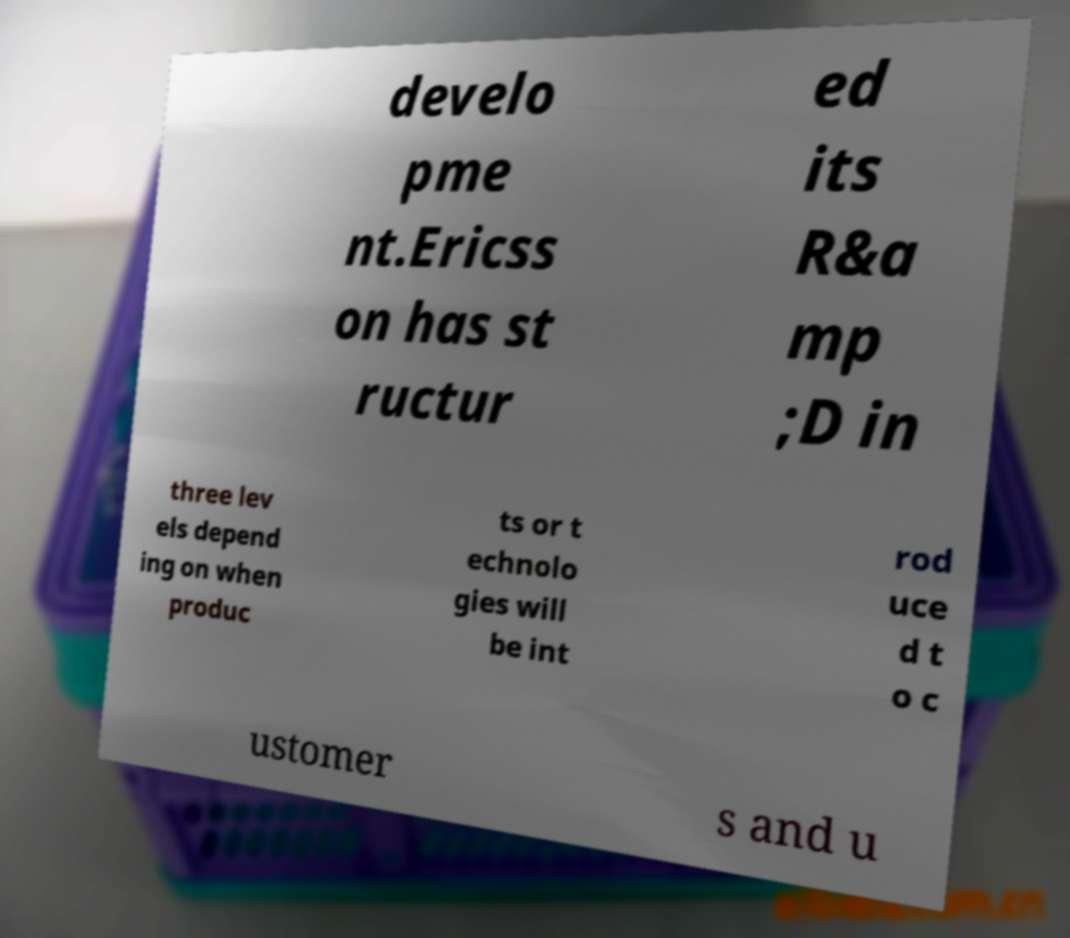Please identify and transcribe the text found in this image. develo pme nt.Ericss on has st ructur ed its R&a mp ;D in three lev els depend ing on when produc ts or t echnolo gies will be int rod uce d t o c ustomer s and u 